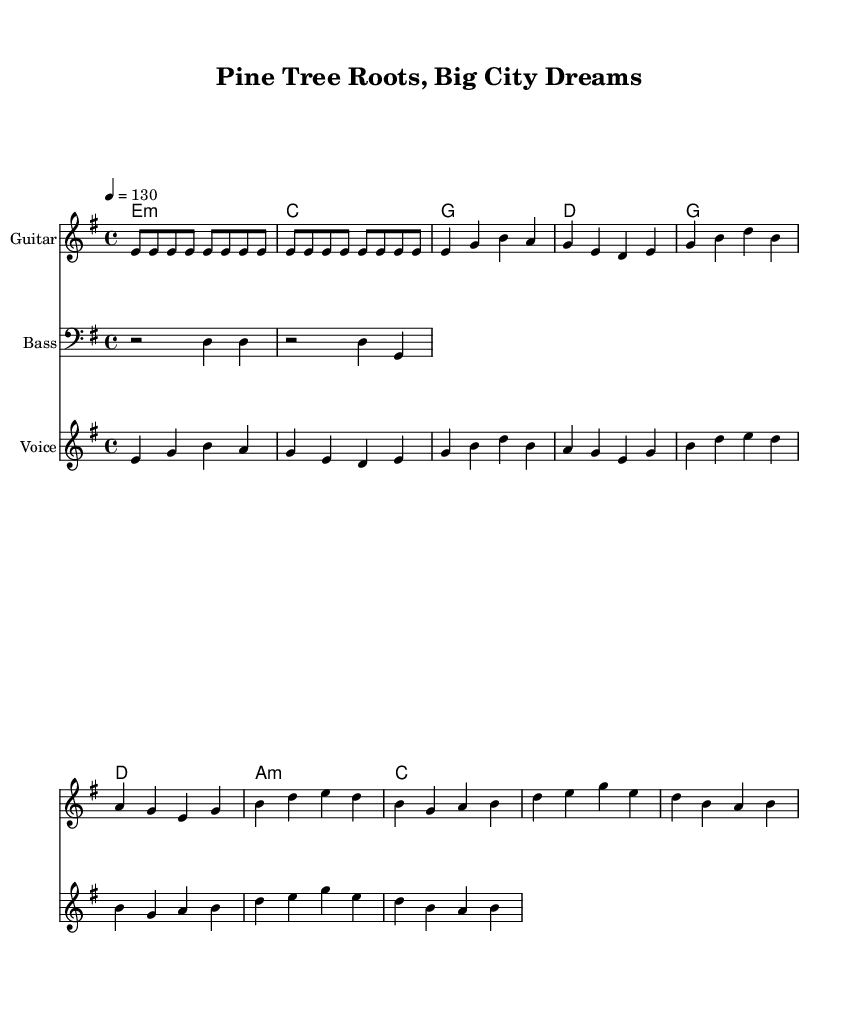What is the key signature of this music? The key signature is E minor, which has one sharp (F#) and is indicated at the beginning of the staff.
Answer: E minor What is the time signature of this piece? The time signature is 4/4, which is presented at the beginning of the sheet music and indicates that there are four beats in each measure.
Answer: 4/4 What is the tempo marking? The tempo marking is 130 beats per minute, which is stated in terms of a metronome marking (4 = 130) right after the time signature.
Answer: 130 How many measures are in the guitar riff? The guitar riff consists of two measures, as evidenced by the use of the vertical lines indicating the end of each measure.
Answer: 2 What are the chords played in the verse? The chords in the verse are E minor, C, G, and D, which are listed in the chord names section corresponding to the first section of the lyrics.
Answer: E minor, C, G, D What is the main theme of the lyrics? The main theme of the lyrics reflects the connection to Maine, highlighting feelings of nostalgia and resilience while adapting to new environments.
Answer: Connection to Maine 